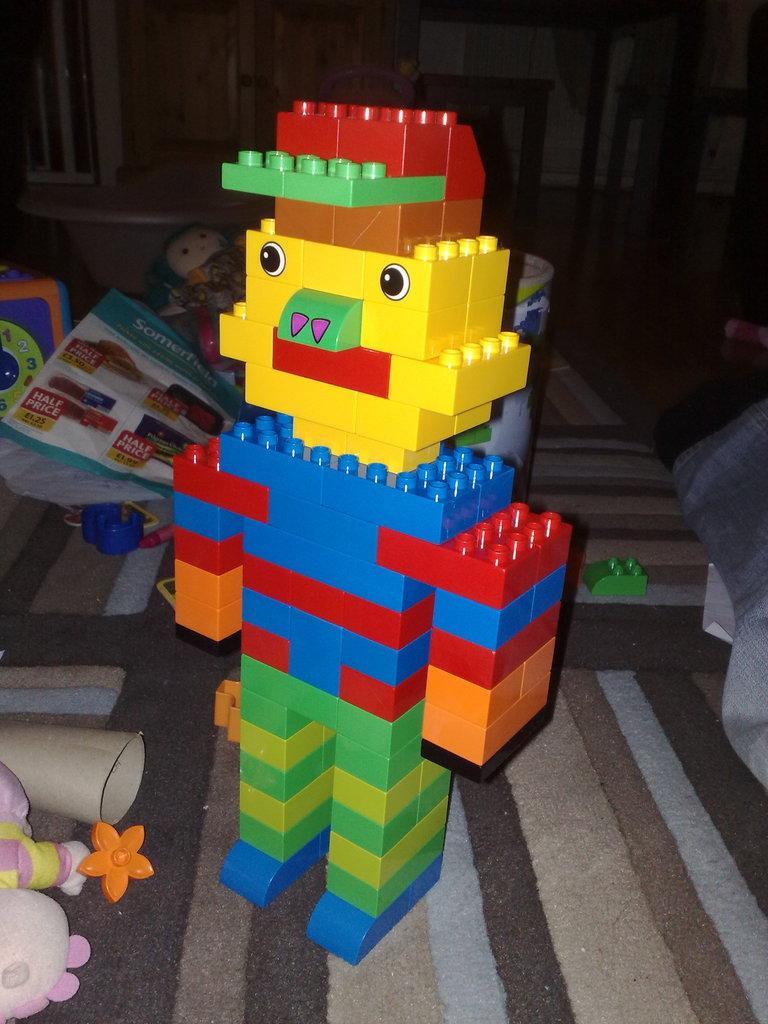How would you summarize this image in a sentence or two? In this image we can see a toy made with Lego which is placed on the surface. We can also see some papers, toys and Lego blocks around it. 